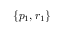<formula> <loc_0><loc_0><loc_500><loc_500>\{ p _ { 1 } , r _ { 1 } \}</formula> 